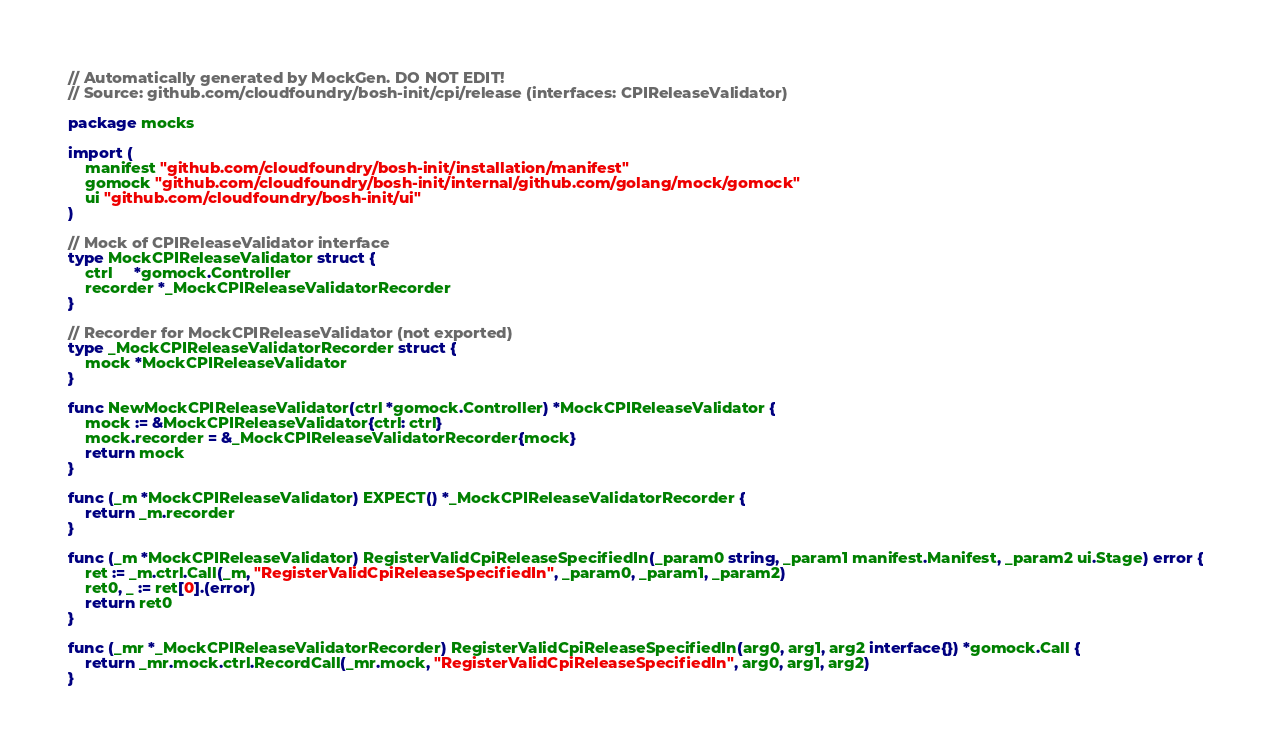<code> <loc_0><loc_0><loc_500><loc_500><_Go_>// Automatically generated by MockGen. DO NOT EDIT!
// Source: github.com/cloudfoundry/bosh-init/cpi/release (interfaces: CPIReleaseValidator)

package mocks

import (
	manifest "github.com/cloudfoundry/bosh-init/installation/manifest"
	gomock "github.com/cloudfoundry/bosh-init/internal/github.com/golang/mock/gomock"
	ui "github.com/cloudfoundry/bosh-init/ui"
)

// Mock of CPIReleaseValidator interface
type MockCPIReleaseValidator struct {
	ctrl     *gomock.Controller
	recorder *_MockCPIReleaseValidatorRecorder
}

// Recorder for MockCPIReleaseValidator (not exported)
type _MockCPIReleaseValidatorRecorder struct {
	mock *MockCPIReleaseValidator
}

func NewMockCPIReleaseValidator(ctrl *gomock.Controller) *MockCPIReleaseValidator {
	mock := &MockCPIReleaseValidator{ctrl: ctrl}
	mock.recorder = &_MockCPIReleaseValidatorRecorder{mock}
	return mock
}

func (_m *MockCPIReleaseValidator) EXPECT() *_MockCPIReleaseValidatorRecorder {
	return _m.recorder
}

func (_m *MockCPIReleaseValidator) RegisterValidCpiReleaseSpecifiedIn(_param0 string, _param1 manifest.Manifest, _param2 ui.Stage) error {
	ret := _m.ctrl.Call(_m, "RegisterValidCpiReleaseSpecifiedIn", _param0, _param1, _param2)
	ret0, _ := ret[0].(error)
	return ret0
}

func (_mr *_MockCPIReleaseValidatorRecorder) RegisterValidCpiReleaseSpecifiedIn(arg0, arg1, arg2 interface{}) *gomock.Call {
	return _mr.mock.ctrl.RecordCall(_mr.mock, "RegisterValidCpiReleaseSpecifiedIn", arg0, arg1, arg2)
}
</code> 